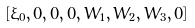<formula> <loc_0><loc_0><loc_500><loc_500>[ \xi _ { 0 } , 0 , 0 , 0 , W _ { 1 } , W _ { 2 } , W _ { 3 } , 0 ]</formula> 